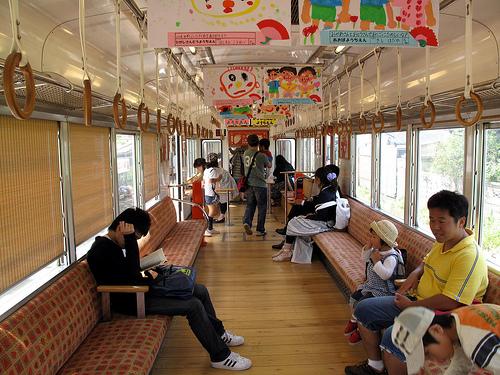<image>
Is there a kid in front of the man? No. The kid is not in front of the man. The spatial positioning shows a different relationship between these objects. 